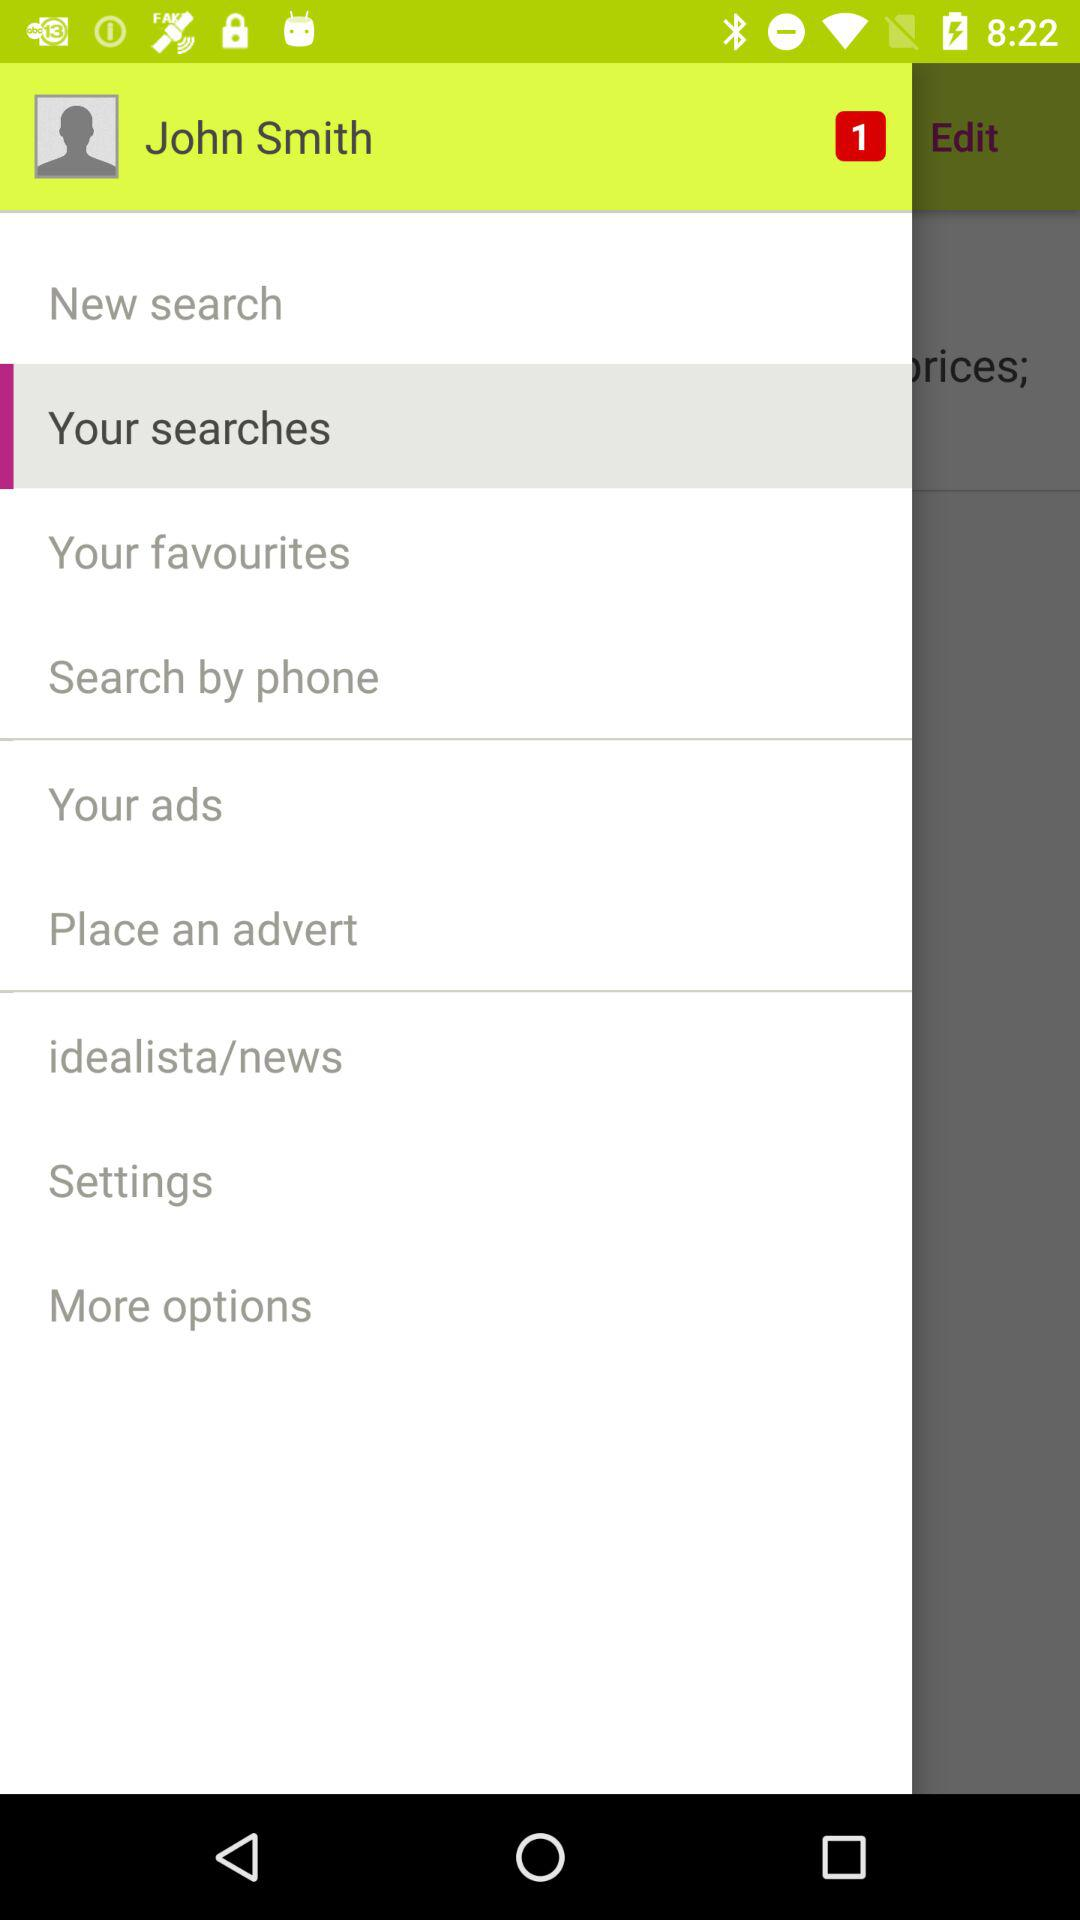What is the name of the user? The name of the user is John Smith. 